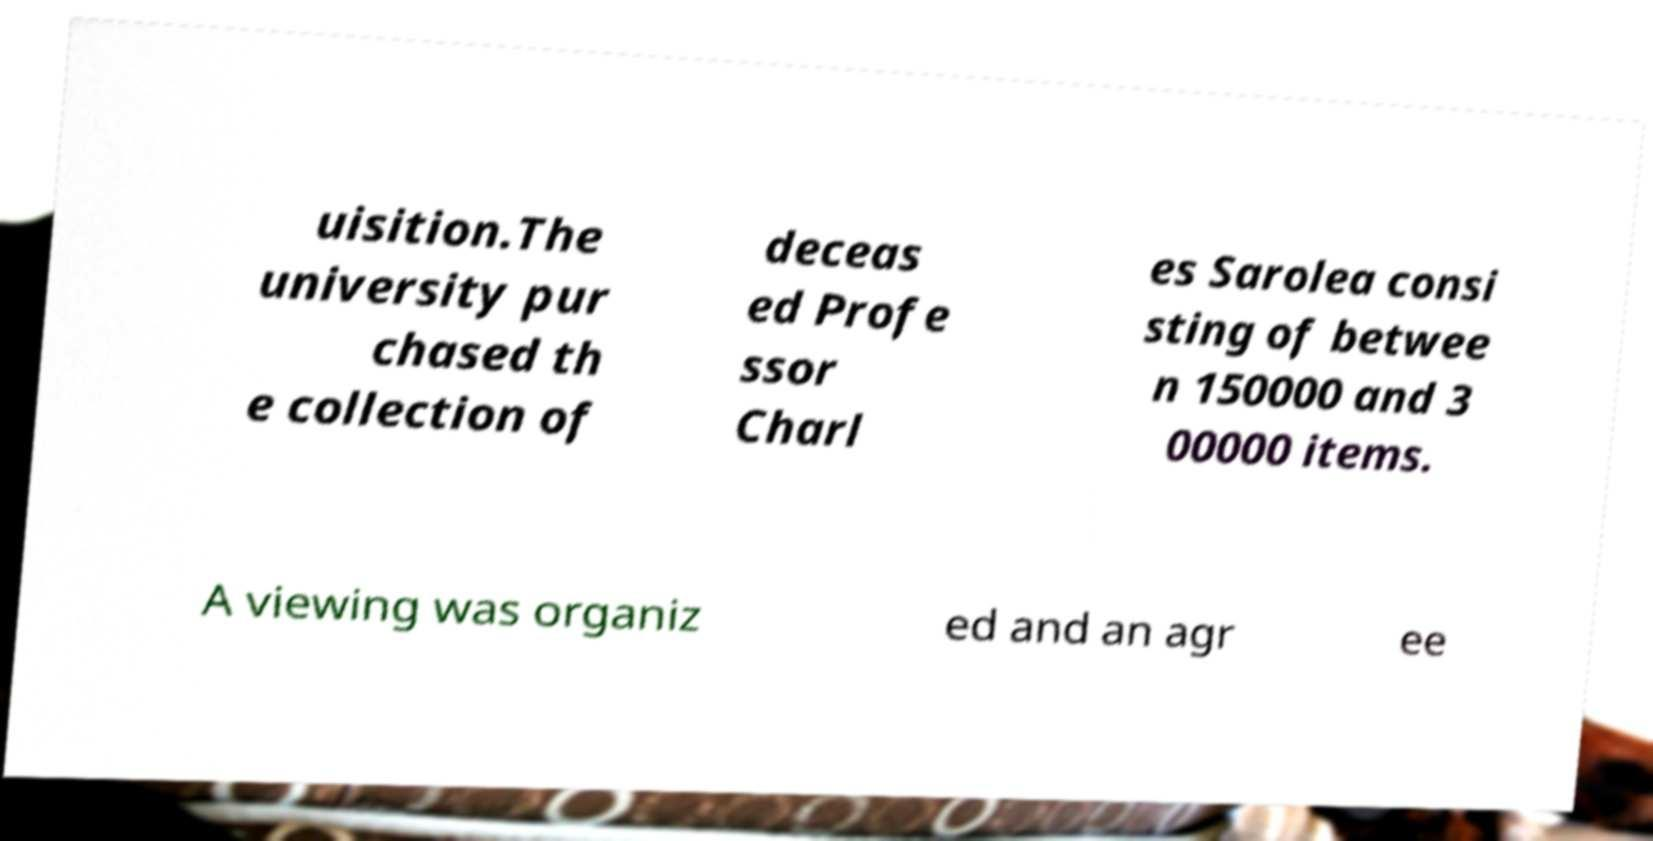There's text embedded in this image that I need extracted. Can you transcribe it verbatim? uisition.The university pur chased th e collection of deceas ed Profe ssor Charl es Sarolea consi sting of betwee n 150000 and 3 00000 items. A viewing was organiz ed and an agr ee 